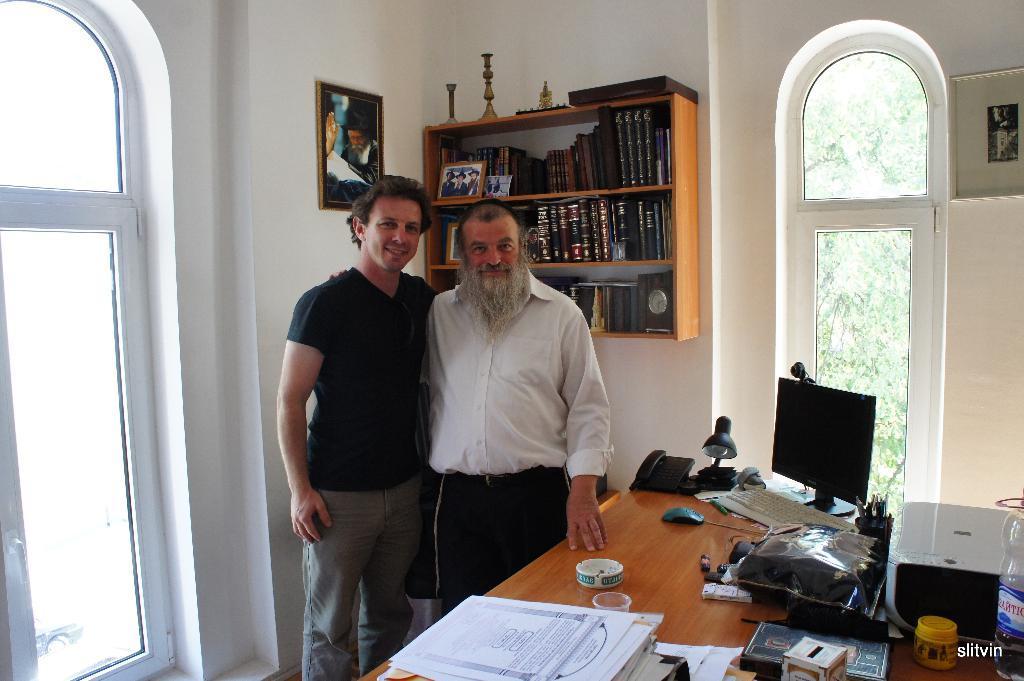Can you describe this image briefly? In this image there are two men standing and smiling. One is wearing a black shirt and another man is wearing a white shirt. There is a table. There is a computer and a keyboard on the table. There is a bed lamp and a telephone on the table. There is a glass on the table and papers on the table. There is a box and a xerox machine on the table. There is a bottle on the table. At the background there is a frame in which a man is there. There is a shelf in which many books are kept. There is another frame in the shelf in which there are three people. There is a tree at the background. 